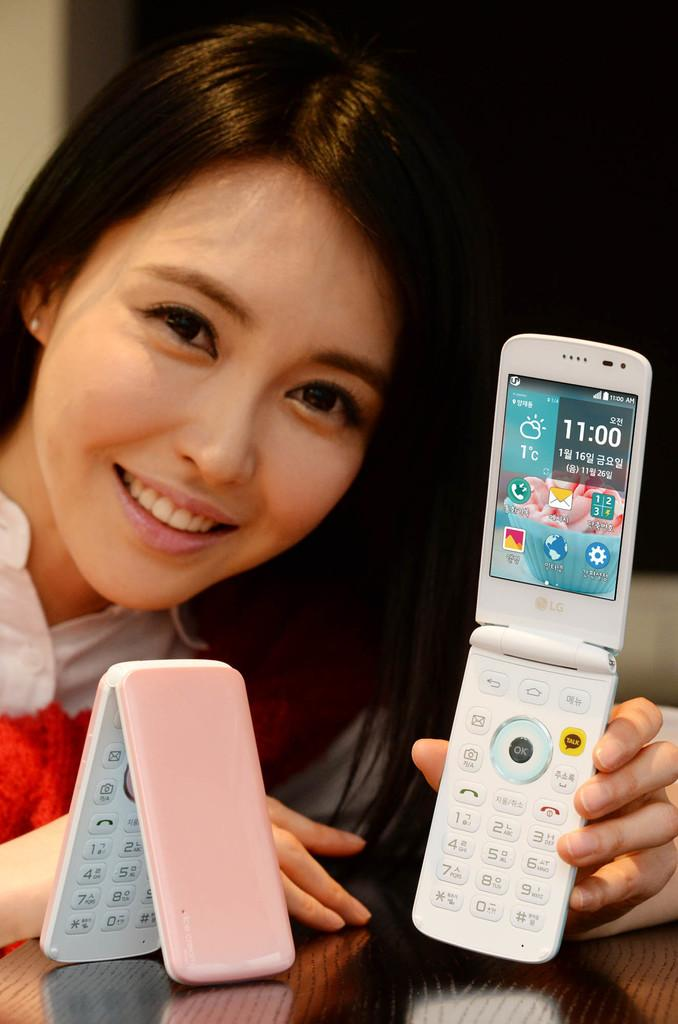<image>
Give a short and clear explanation of the subsequent image. Woman holding a smartphone from LG that says 11:00, 1 degree celsius. 